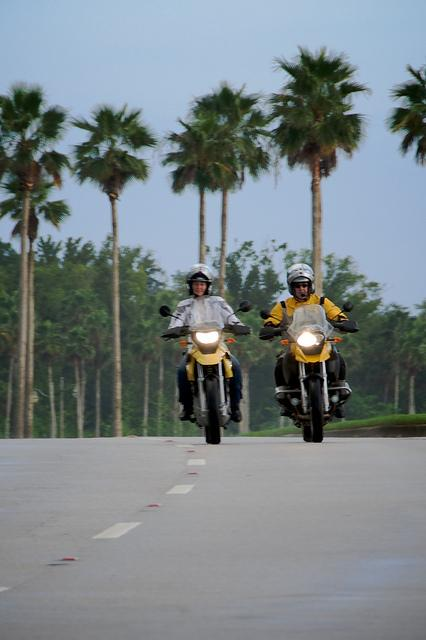What type of vehicle are the men riding?

Choices:
A) train
B) motorcycle
C) car
D) bus motorcycle 